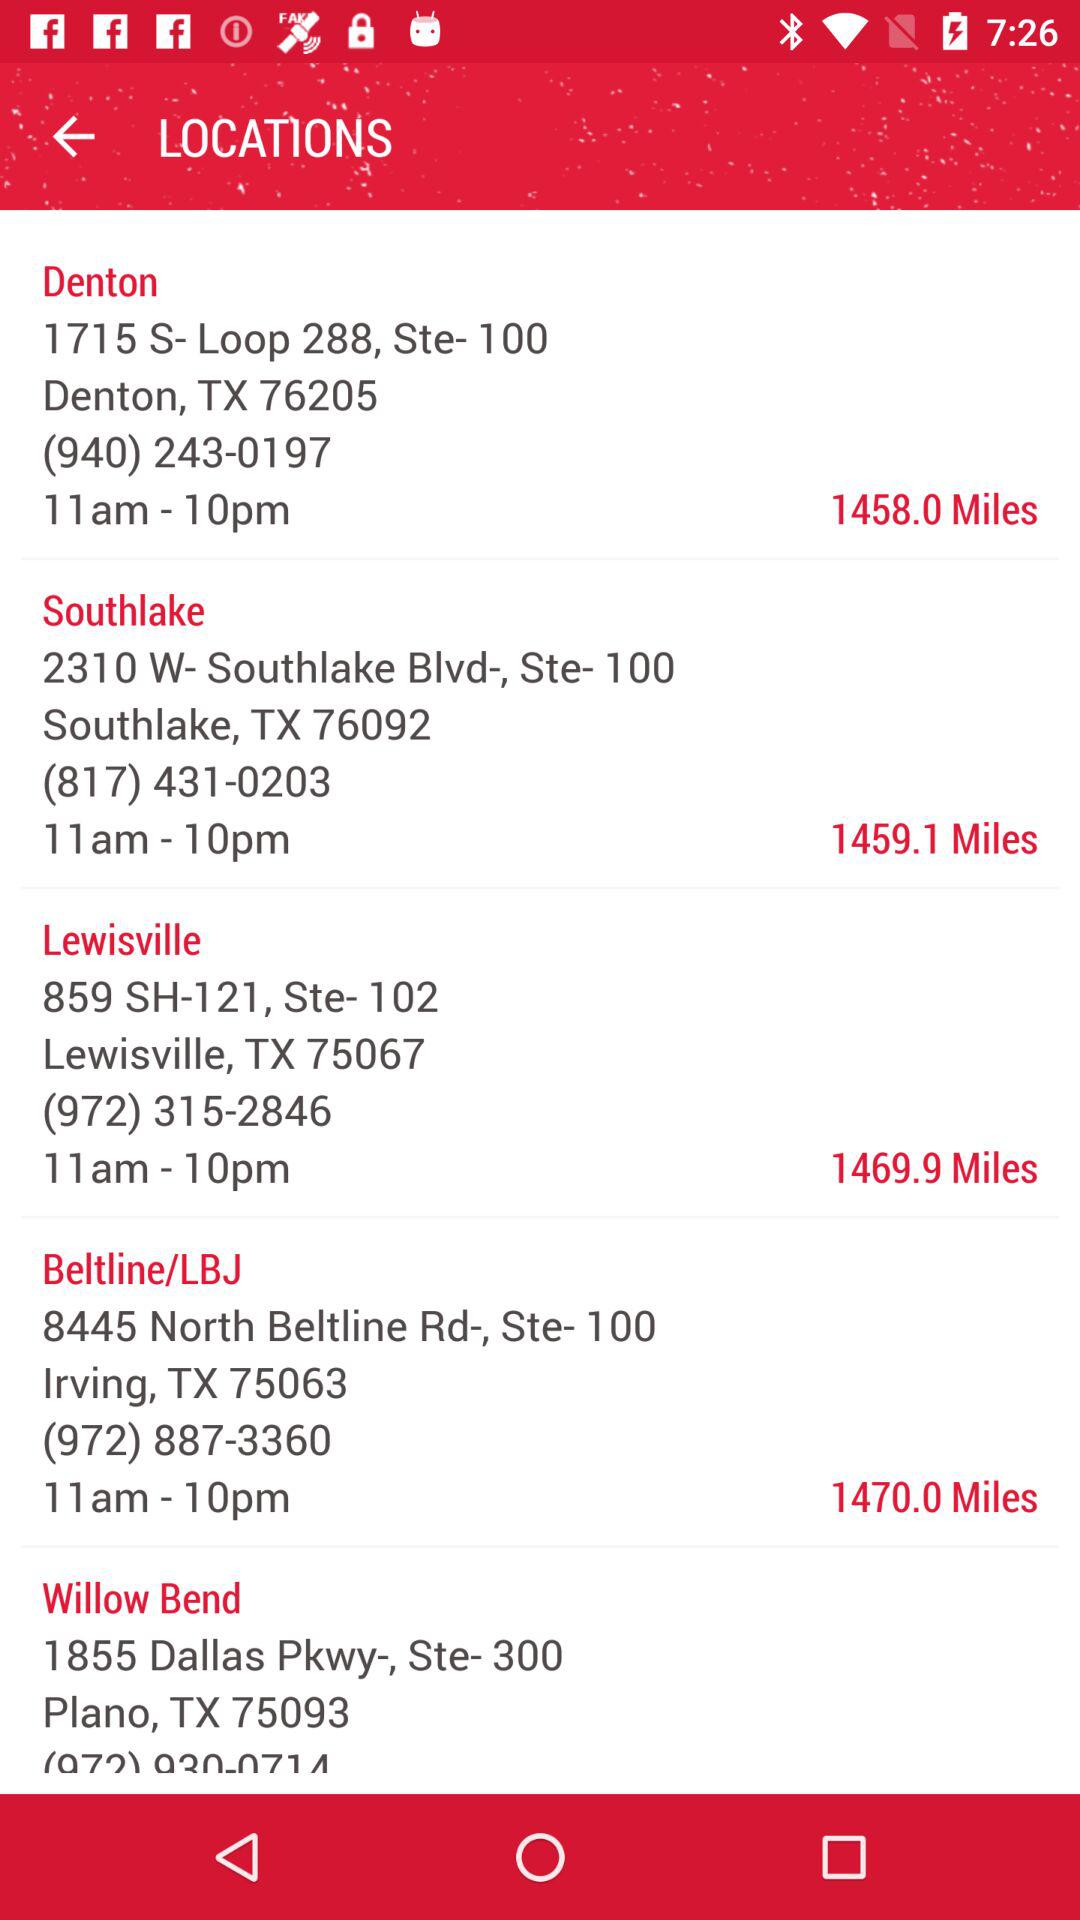What is the contact number for "Denton"? The contact number is (940) 243-0197. 